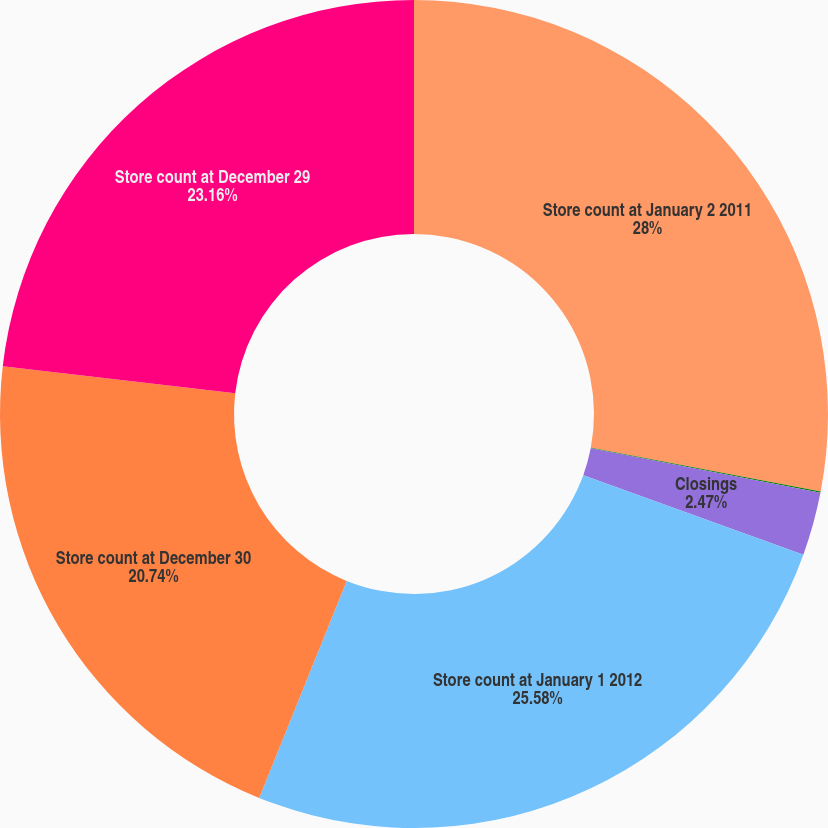Convert chart to OTSL. <chart><loc_0><loc_0><loc_500><loc_500><pie_chart><fcel>Store count at January 2 2011<fcel>Openings<fcel>Closings<fcel>Store count at January 1 2012<fcel>Store count at December 30<fcel>Store count at December 29<nl><fcel>28.0%<fcel>0.05%<fcel>2.47%<fcel>25.58%<fcel>20.74%<fcel>23.16%<nl></chart> 